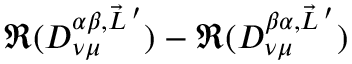Convert formula to latex. <formula><loc_0><loc_0><loc_500><loc_500>\Re ( D _ { \nu \mu } ^ { \alpha \beta , \vec { L } \, ^ { \prime } } ) - \Re ( D _ { \nu \mu } ^ { \beta \alpha , \vec { L } \, ^ { \prime } } )</formula> 